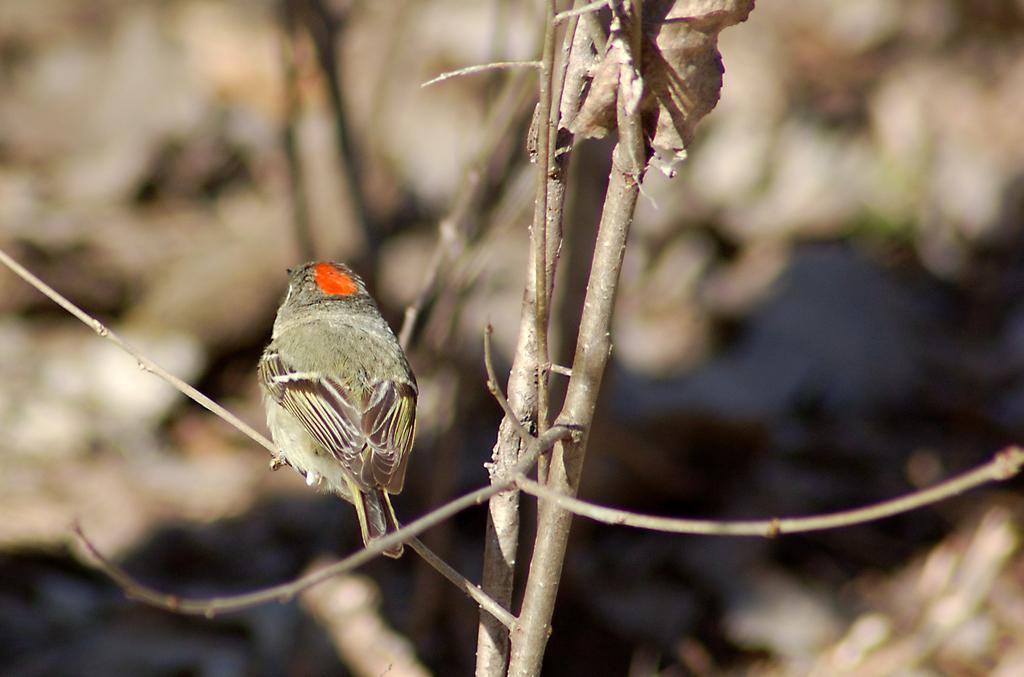How would you summarize this image in a sentence or two? As we can see in the image there is a bird and plant. The background is blurred. 